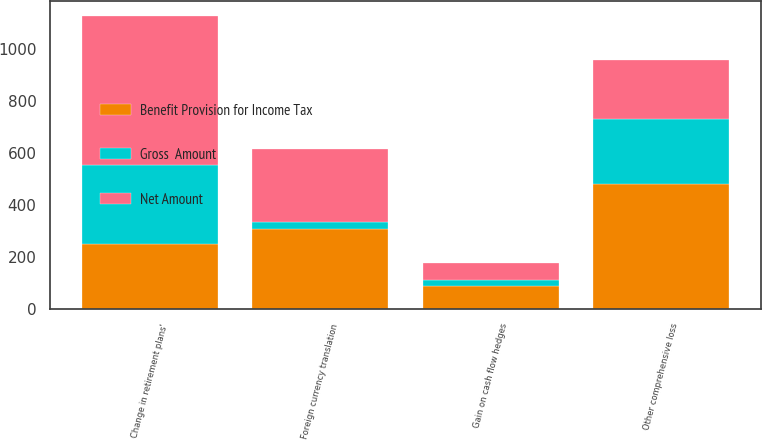Convert chart to OTSL. <chart><loc_0><loc_0><loc_500><loc_500><stacked_bar_chart><ecel><fcel>Gain on cash flow hedges<fcel>Foreign currency translation<fcel>Change in retirement plans'<fcel>Other comprehensive loss<nl><fcel>Benefit Provision for Income Tax<fcel>89<fcel>308<fcel>251<fcel>480<nl><fcel>Gross  Amount<fcel>23<fcel>29<fcel>303<fcel>251<nl><fcel>Net Amount<fcel>66<fcel>279<fcel>575<fcel>229<nl></chart> 